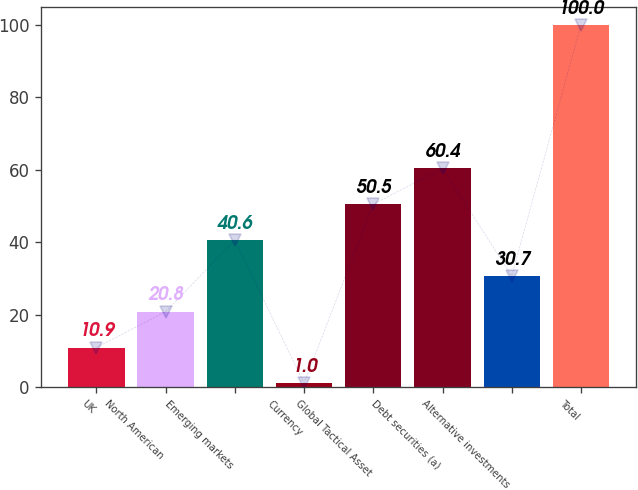<chart> <loc_0><loc_0><loc_500><loc_500><bar_chart><fcel>UK<fcel>North American<fcel>Emerging markets<fcel>Currency<fcel>Global Tactical Asset<fcel>Debt securities (a)<fcel>Alternative investments<fcel>Total<nl><fcel>10.9<fcel>20.8<fcel>40.6<fcel>1<fcel>50.5<fcel>60.4<fcel>30.7<fcel>100<nl></chart> 